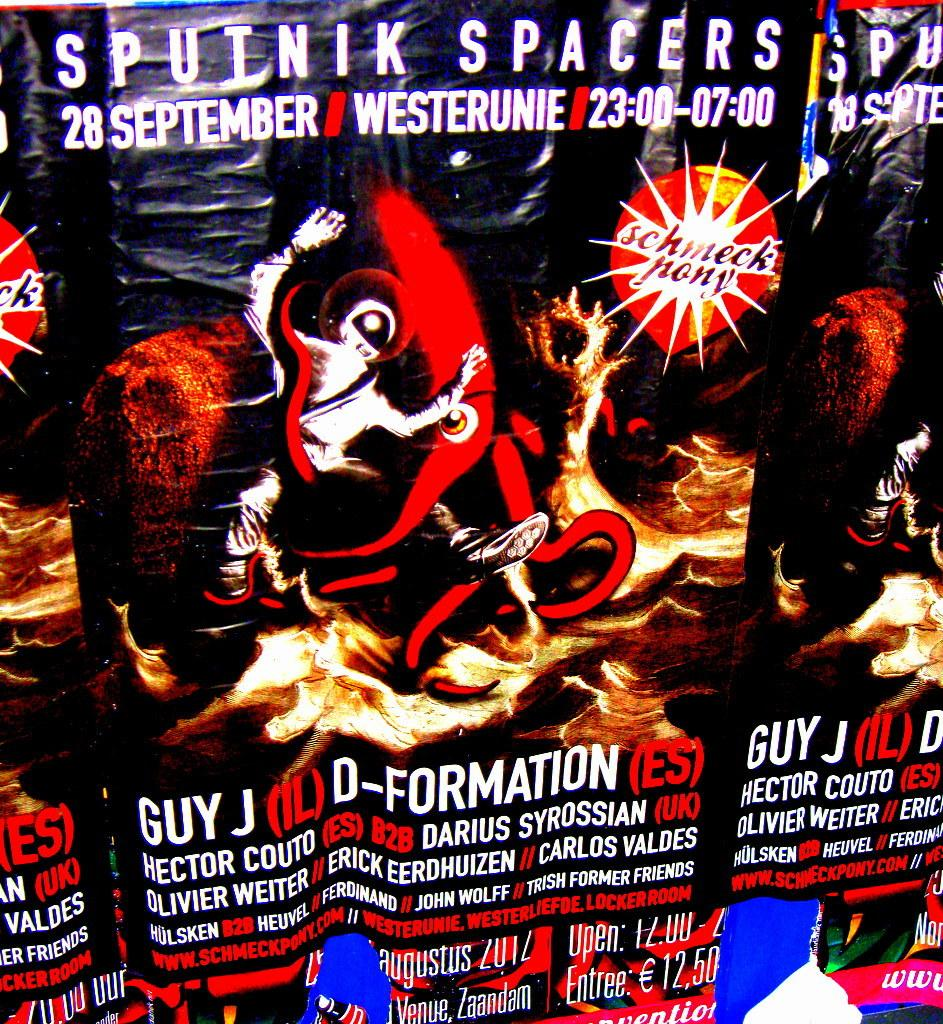<image>
Offer a succinct explanation of the picture presented. an ad that has Sputnik Spacers on it 